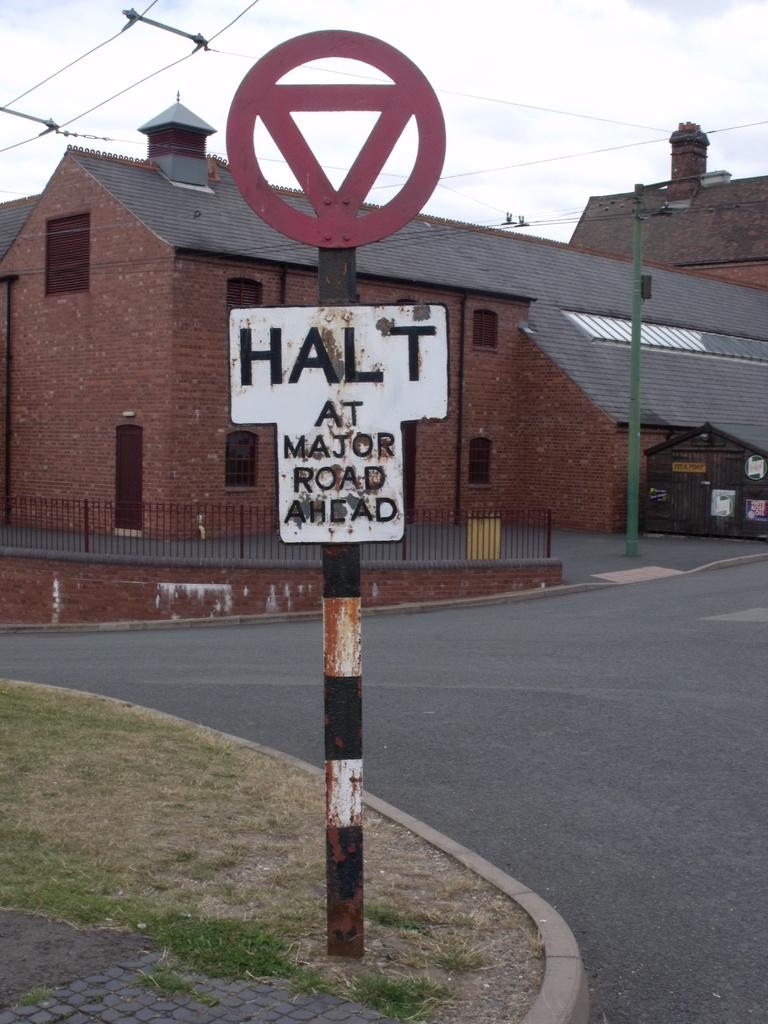<image>
Present a compact description of the photo's key features. A sign warning to halt at the major road ahead is posted. 